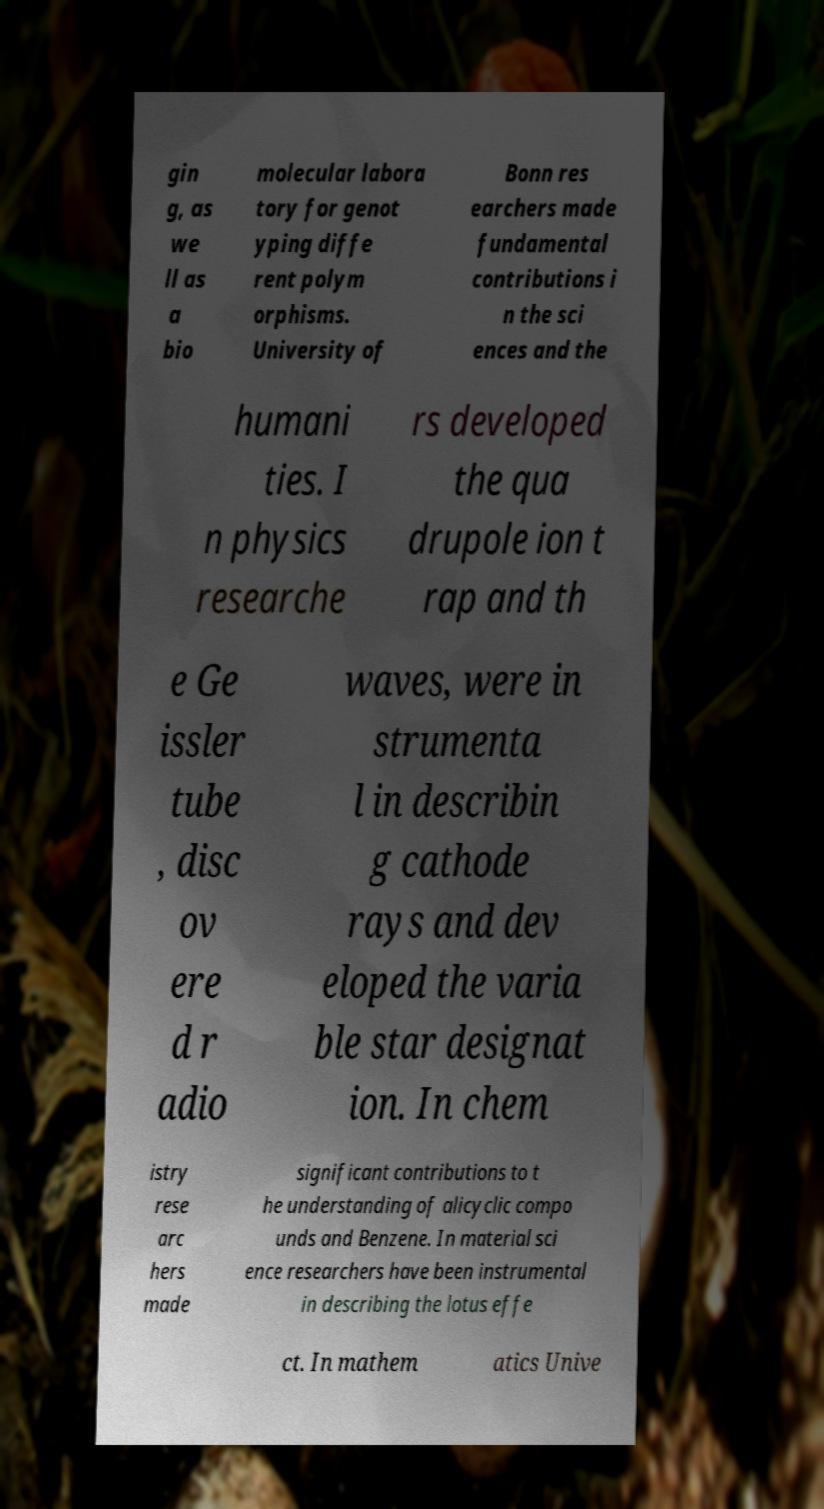For documentation purposes, I need the text within this image transcribed. Could you provide that? gin g, as we ll as a bio molecular labora tory for genot yping diffe rent polym orphisms. University of Bonn res earchers made fundamental contributions i n the sci ences and the humani ties. I n physics researche rs developed the qua drupole ion t rap and th e Ge issler tube , disc ov ere d r adio waves, were in strumenta l in describin g cathode rays and dev eloped the varia ble star designat ion. In chem istry rese arc hers made significant contributions to t he understanding of alicyclic compo unds and Benzene. In material sci ence researchers have been instrumental in describing the lotus effe ct. In mathem atics Unive 